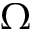<formula> <loc_0><loc_0><loc_500><loc_500>\Omega</formula> 